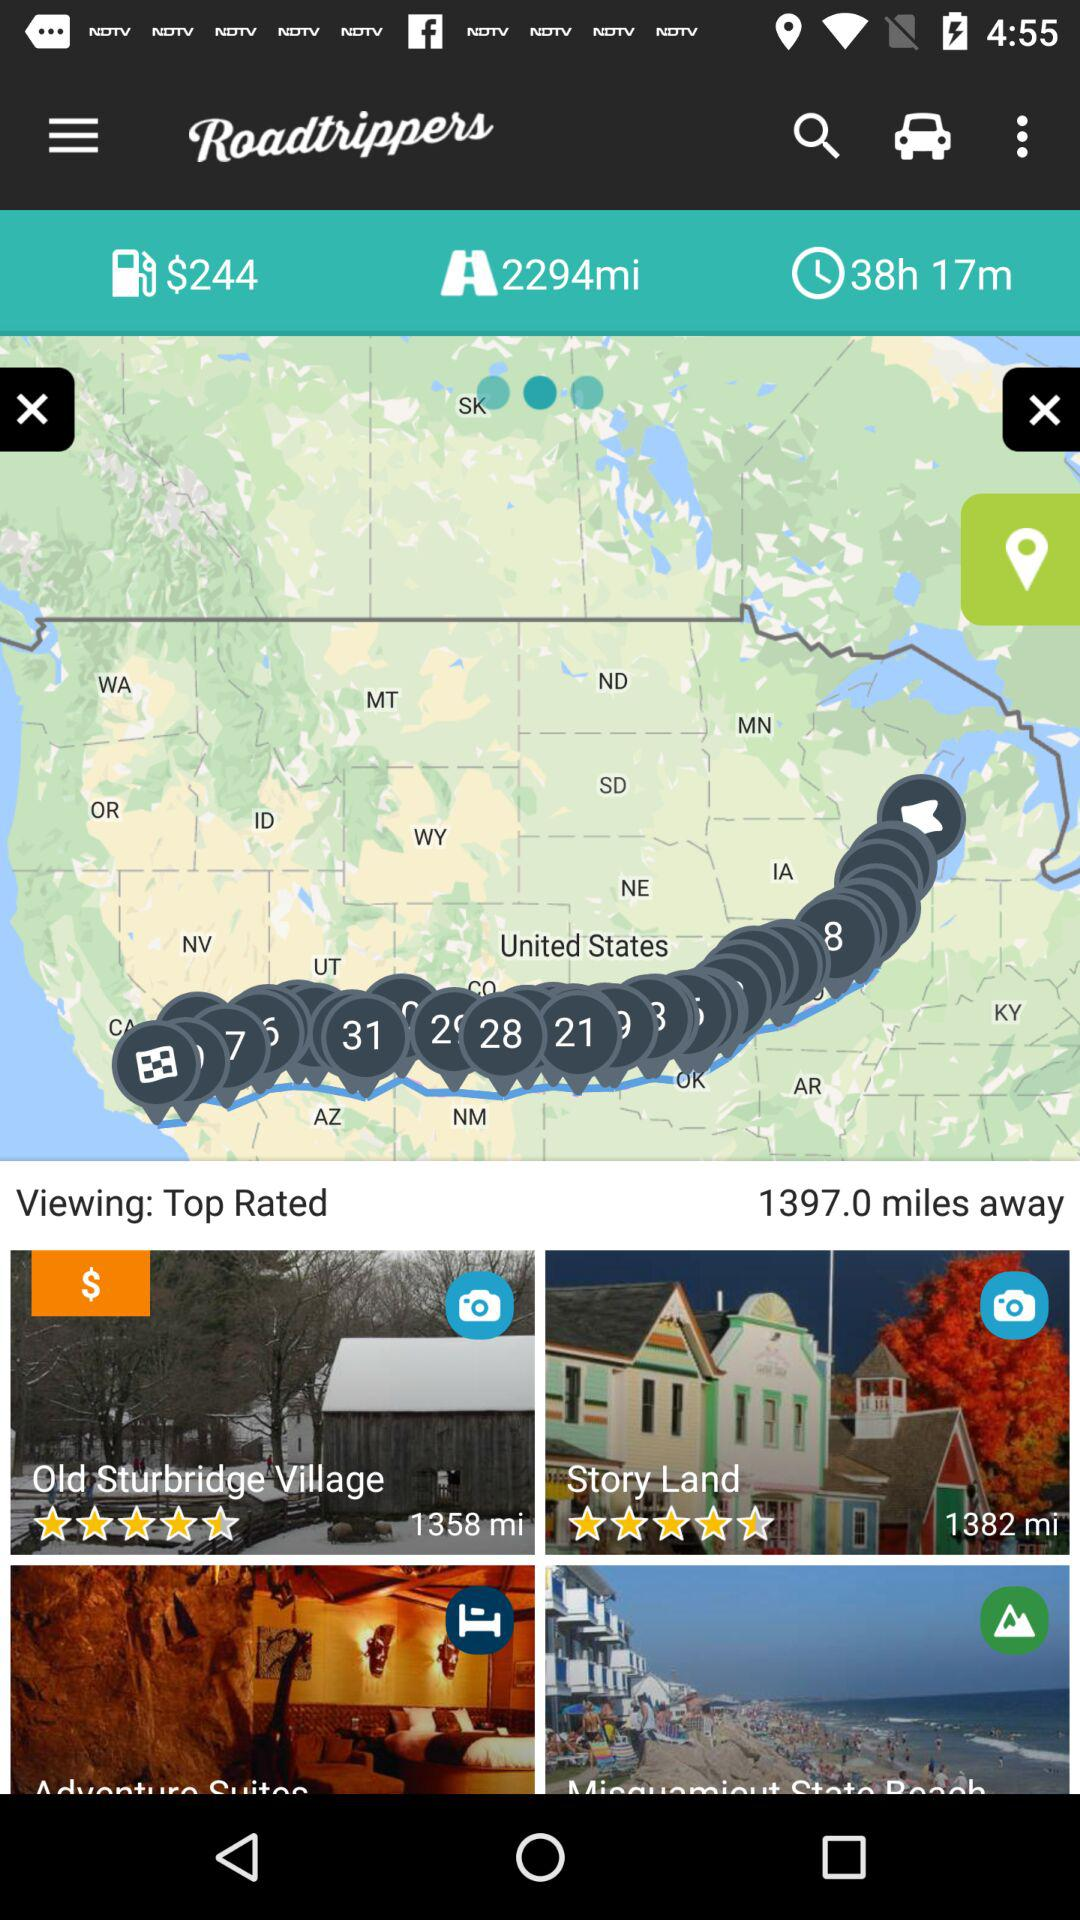What is the total fuel price of a road trip? The total fuel price of a road trip is $244. 